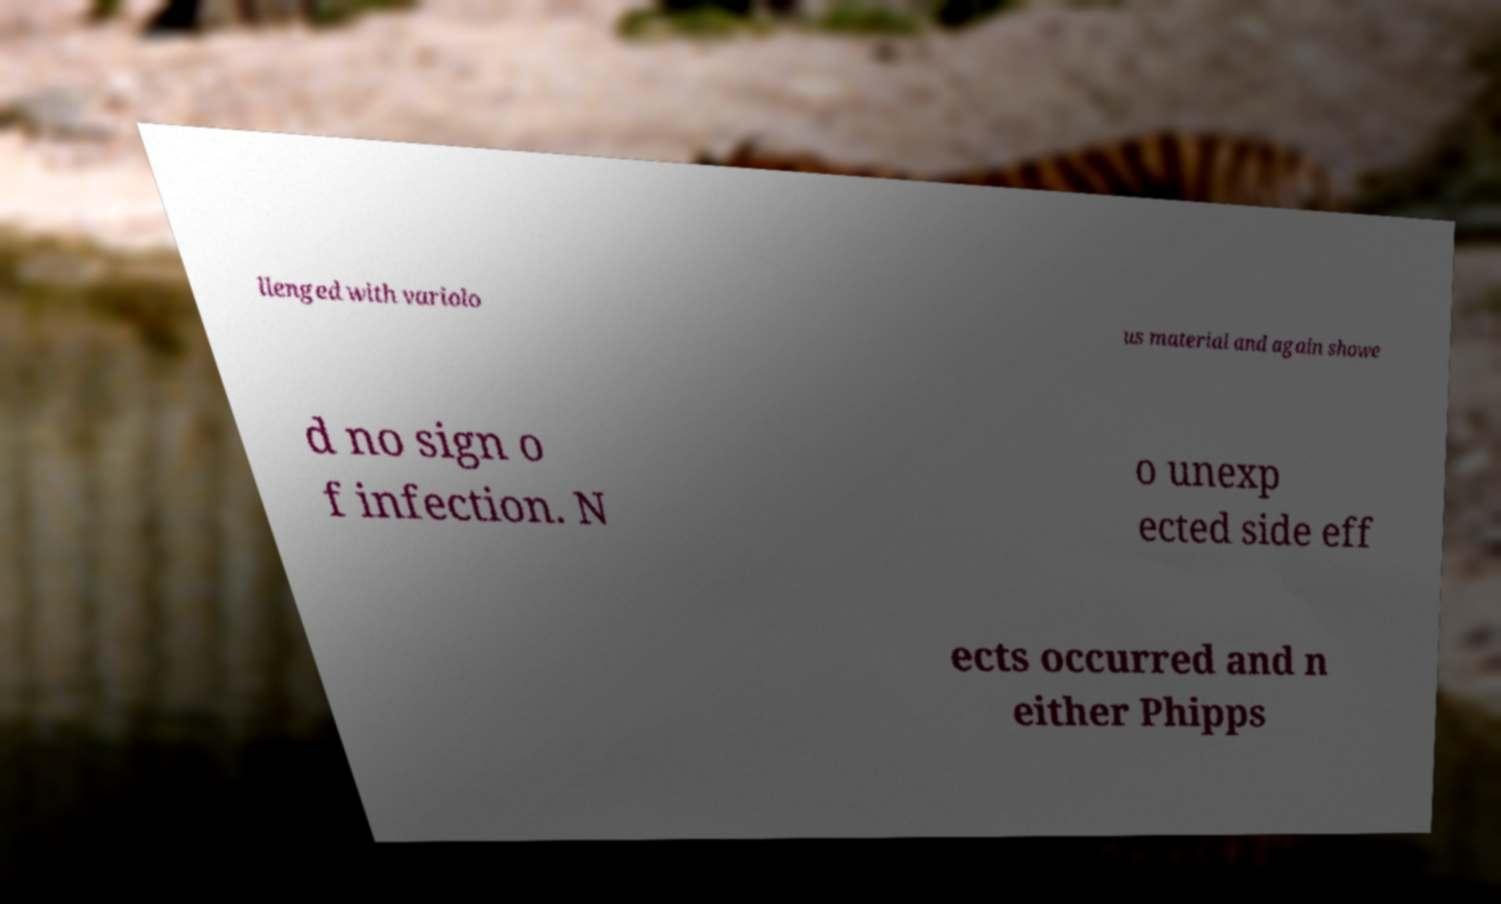Can you accurately transcribe the text from the provided image for me? llenged with variolo us material and again showe d no sign o f infection. N o unexp ected side eff ects occurred and n either Phipps 